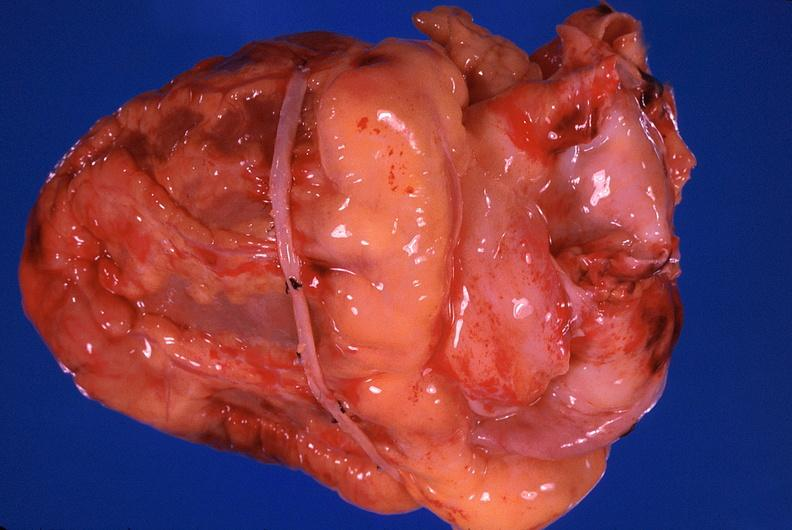does myocardium show heart, recent coronary artery bypass graft?
Answer the question using a single word or phrase. No 